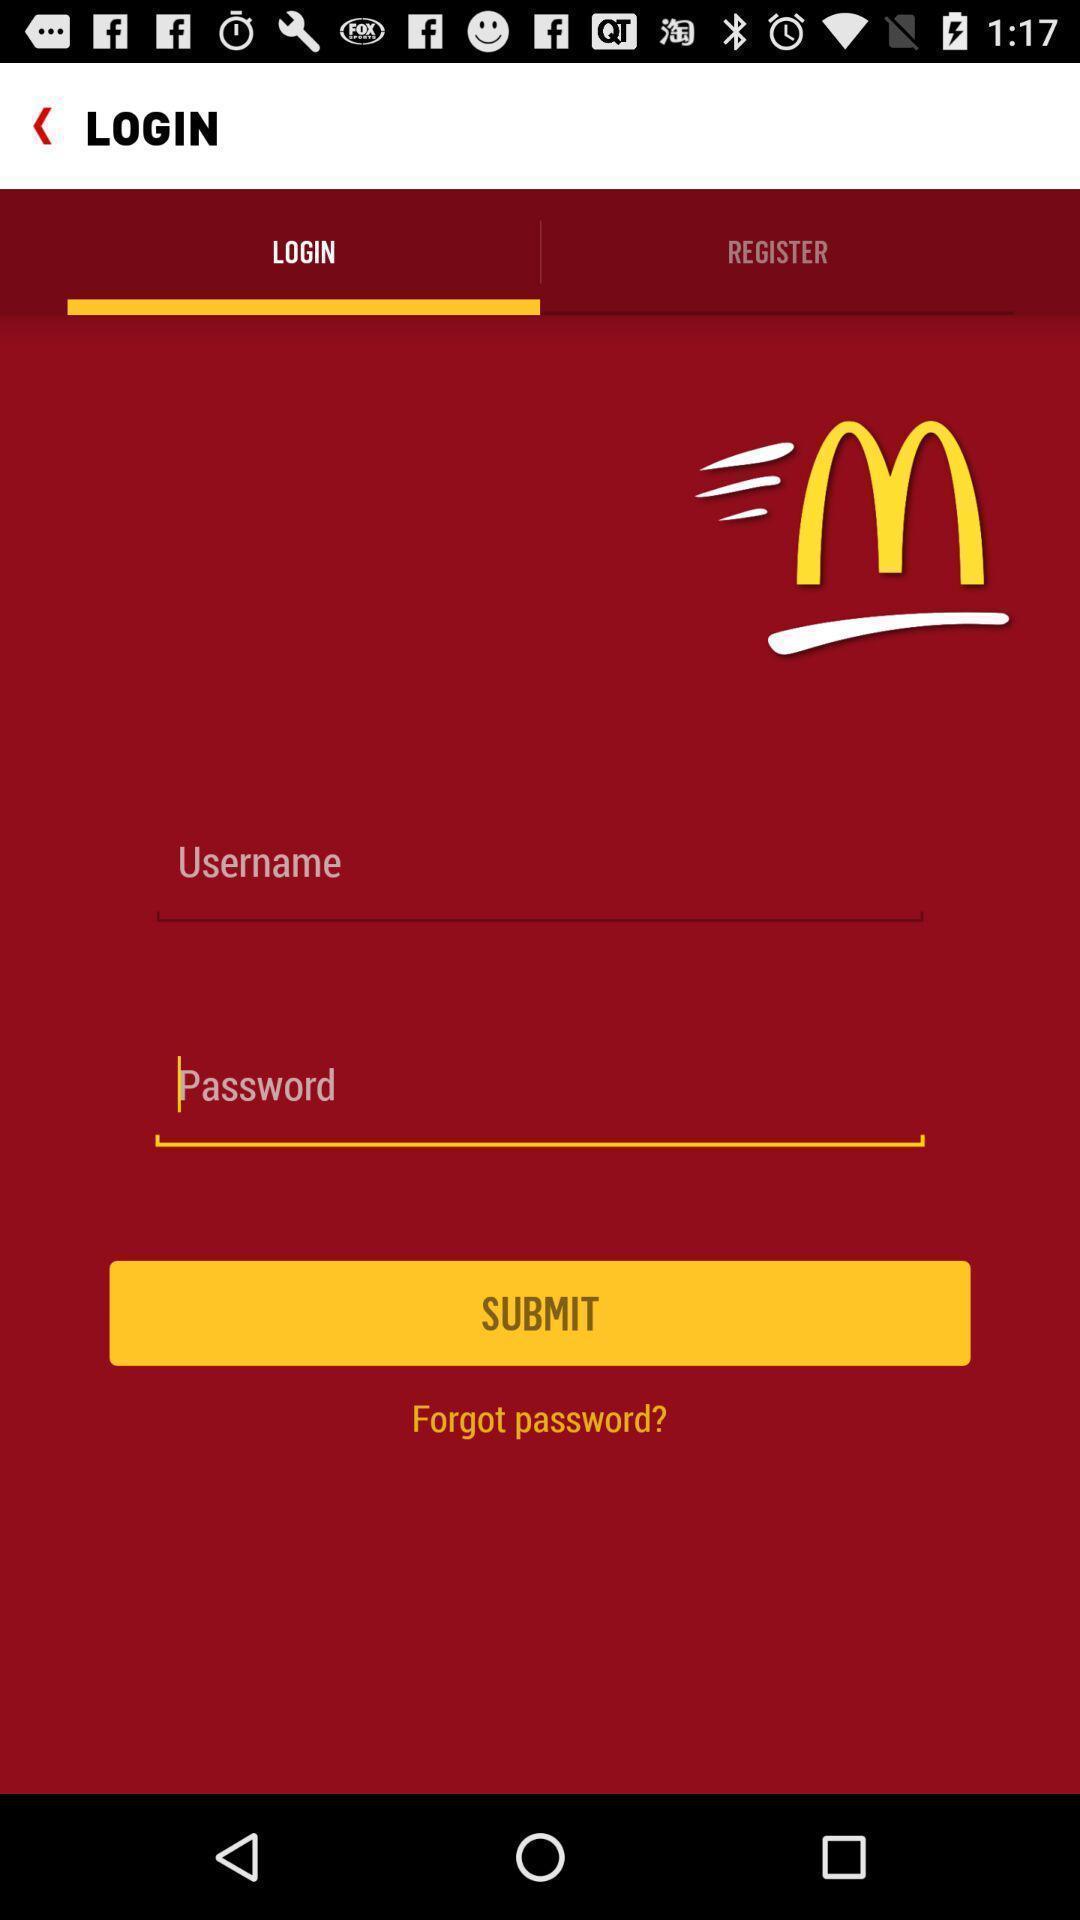Summarize the information in this screenshot. Screen displaying the login page of food ordering app. 